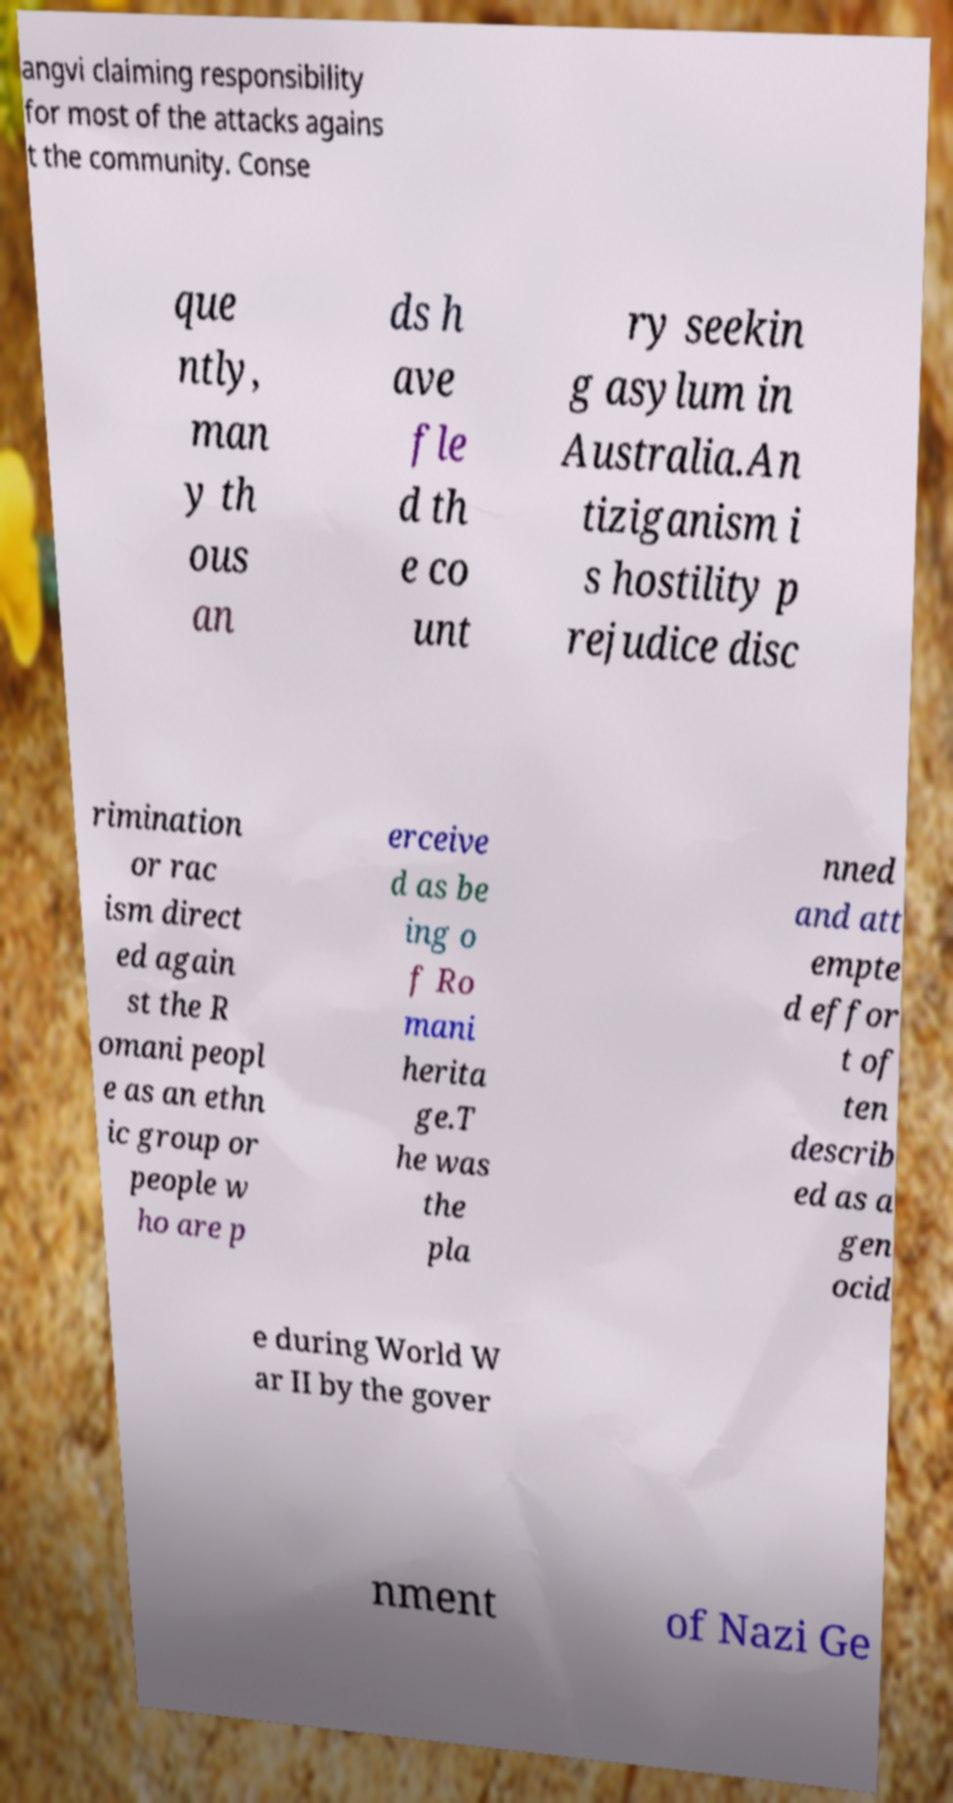Can you accurately transcribe the text from the provided image for me? angvi claiming responsibility for most of the attacks agains t the community. Conse que ntly, man y th ous an ds h ave fle d th e co unt ry seekin g asylum in Australia.An tiziganism i s hostility p rejudice disc rimination or rac ism direct ed again st the R omani peopl e as an ethn ic group or people w ho are p erceive d as be ing o f Ro mani herita ge.T he was the pla nned and att empte d effor t of ten describ ed as a gen ocid e during World W ar II by the gover nment of Nazi Ge 